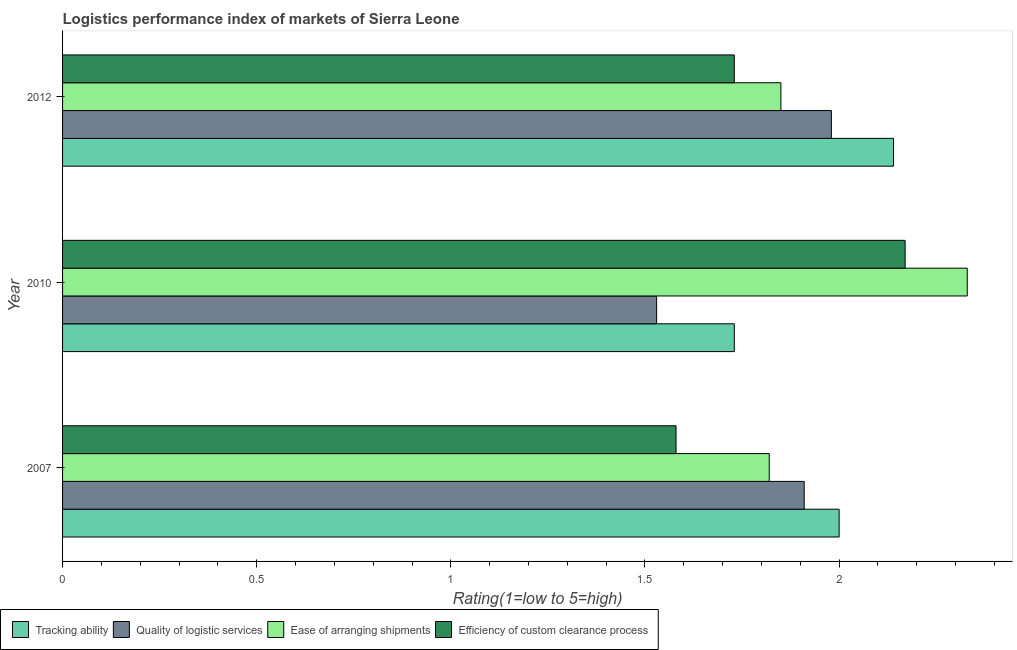How many groups of bars are there?
Give a very brief answer. 3. Are the number of bars per tick equal to the number of legend labels?
Offer a terse response. Yes. How many bars are there on the 2nd tick from the bottom?
Offer a terse response. 4. What is the lpi rating of efficiency of custom clearance process in 2012?
Your answer should be very brief. 1.73. Across all years, what is the maximum lpi rating of ease of arranging shipments?
Ensure brevity in your answer.  2.33. Across all years, what is the minimum lpi rating of quality of logistic services?
Ensure brevity in your answer.  1.53. In which year was the lpi rating of quality of logistic services maximum?
Make the answer very short. 2012. What is the total lpi rating of ease of arranging shipments in the graph?
Keep it short and to the point. 6. What is the difference between the lpi rating of efficiency of custom clearance process in 2007 and that in 2012?
Your answer should be very brief. -0.15. What is the difference between the lpi rating of ease of arranging shipments in 2010 and the lpi rating of tracking ability in 2007?
Offer a terse response. 0.33. What is the average lpi rating of ease of arranging shipments per year?
Give a very brief answer. 2. In the year 2012, what is the difference between the lpi rating of tracking ability and lpi rating of quality of logistic services?
Make the answer very short. 0.16. In how many years, is the lpi rating of tracking ability greater than 1.7 ?
Ensure brevity in your answer.  3. What is the ratio of the lpi rating of efficiency of custom clearance process in 2007 to that in 2010?
Provide a short and direct response. 0.73. Is the lpi rating of quality of logistic services in 2010 less than that in 2012?
Your answer should be compact. Yes. Is the difference between the lpi rating of tracking ability in 2010 and 2012 greater than the difference between the lpi rating of ease of arranging shipments in 2010 and 2012?
Your answer should be very brief. No. What is the difference between the highest and the second highest lpi rating of efficiency of custom clearance process?
Provide a short and direct response. 0.44. What is the difference between the highest and the lowest lpi rating of efficiency of custom clearance process?
Provide a succinct answer. 0.59. In how many years, is the lpi rating of ease of arranging shipments greater than the average lpi rating of ease of arranging shipments taken over all years?
Offer a very short reply. 1. Is the sum of the lpi rating of quality of logistic services in 2007 and 2010 greater than the maximum lpi rating of tracking ability across all years?
Ensure brevity in your answer.  Yes. Is it the case that in every year, the sum of the lpi rating of quality of logistic services and lpi rating of tracking ability is greater than the sum of lpi rating of ease of arranging shipments and lpi rating of efficiency of custom clearance process?
Provide a short and direct response. No. What does the 2nd bar from the top in 2007 represents?
Keep it short and to the point. Ease of arranging shipments. What does the 4th bar from the bottom in 2007 represents?
Provide a succinct answer. Efficiency of custom clearance process. Is it the case that in every year, the sum of the lpi rating of tracking ability and lpi rating of quality of logistic services is greater than the lpi rating of ease of arranging shipments?
Provide a succinct answer. Yes. Are all the bars in the graph horizontal?
Keep it short and to the point. Yes. How many years are there in the graph?
Ensure brevity in your answer.  3. What is the difference between two consecutive major ticks on the X-axis?
Keep it short and to the point. 0.5. Are the values on the major ticks of X-axis written in scientific E-notation?
Offer a very short reply. No. Does the graph contain any zero values?
Your response must be concise. No. Does the graph contain grids?
Offer a terse response. No. What is the title of the graph?
Provide a succinct answer. Logistics performance index of markets of Sierra Leone. Does "Labor Taxes" appear as one of the legend labels in the graph?
Offer a very short reply. No. What is the label or title of the X-axis?
Give a very brief answer. Rating(1=low to 5=high). What is the Rating(1=low to 5=high) in Quality of logistic services in 2007?
Offer a terse response. 1.91. What is the Rating(1=low to 5=high) in Ease of arranging shipments in 2007?
Make the answer very short. 1.82. What is the Rating(1=low to 5=high) of Efficiency of custom clearance process in 2007?
Your answer should be compact. 1.58. What is the Rating(1=low to 5=high) in Tracking ability in 2010?
Provide a short and direct response. 1.73. What is the Rating(1=low to 5=high) of Quality of logistic services in 2010?
Your response must be concise. 1.53. What is the Rating(1=low to 5=high) of Ease of arranging shipments in 2010?
Give a very brief answer. 2.33. What is the Rating(1=low to 5=high) of Efficiency of custom clearance process in 2010?
Give a very brief answer. 2.17. What is the Rating(1=low to 5=high) in Tracking ability in 2012?
Your answer should be compact. 2.14. What is the Rating(1=low to 5=high) in Quality of logistic services in 2012?
Make the answer very short. 1.98. What is the Rating(1=low to 5=high) of Ease of arranging shipments in 2012?
Make the answer very short. 1.85. What is the Rating(1=low to 5=high) in Efficiency of custom clearance process in 2012?
Your answer should be compact. 1.73. Across all years, what is the maximum Rating(1=low to 5=high) of Tracking ability?
Provide a succinct answer. 2.14. Across all years, what is the maximum Rating(1=low to 5=high) of Quality of logistic services?
Keep it short and to the point. 1.98. Across all years, what is the maximum Rating(1=low to 5=high) of Ease of arranging shipments?
Offer a very short reply. 2.33. Across all years, what is the maximum Rating(1=low to 5=high) in Efficiency of custom clearance process?
Offer a terse response. 2.17. Across all years, what is the minimum Rating(1=low to 5=high) in Tracking ability?
Offer a very short reply. 1.73. Across all years, what is the minimum Rating(1=low to 5=high) in Quality of logistic services?
Offer a very short reply. 1.53. Across all years, what is the minimum Rating(1=low to 5=high) of Ease of arranging shipments?
Make the answer very short. 1.82. Across all years, what is the minimum Rating(1=low to 5=high) in Efficiency of custom clearance process?
Give a very brief answer. 1.58. What is the total Rating(1=low to 5=high) of Tracking ability in the graph?
Offer a terse response. 5.87. What is the total Rating(1=low to 5=high) of Quality of logistic services in the graph?
Offer a very short reply. 5.42. What is the total Rating(1=low to 5=high) of Ease of arranging shipments in the graph?
Your answer should be compact. 6. What is the total Rating(1=low to 5=high) in Efficiency of custom clearance process in the graph?
Offer a very short reply. 5.48. What is the difference between the Rating(1=low to 5=high) of Tracking ability in 2007 and that in 2010?
Your response must be concise. 0.27. What is the difference between the Rating(1=low to 5=high) in Quality of logistic services in 2007 and that in 2010?
Your answer should be very brief. 0.38. What is the difference between the Rating(1=low to 5=high) in Ease of arranging shipments in 2007 and that in 2010?
Your answer should be very brief. -0.51. What is the difference between the Rating(1=low to 5=high) of Efficiency of custom clearance process in 2007 and that in 2010?
Your answer should be very brief. -0.59. What is the difference between the Rating(1=low to 5=high) in Tracking ability in 2007 and that in 2012?
Give a very brief answer. -0.14. What is the difference between the Rating(1=low to 5=high) of Quality of logistic services in 2007 and that in 2012?
Keep it short and to the point. -0.07. What is the difference between the Rating(1=low to 5=high) in Ease of arranging shipments in 2007 and that in 2012?
Give a very brief answer. -0.03. What is the difference between the Rating(1=low to 5=high) in Efficiency of custom clearance process in 2007 and that in 2012?
Keep it short and to the point. -0.15. What is the difference between the Rating(1=low to 5=high) of Tracking ability in 2010 and that in 2012?
Give a very brief answer. -0.41. What is the difference between the Rating(1=low to 5=high) of Quality of logistic services in 2010 and that in 2012?
Provide a succinct answer. -0.45. What is the difference between the Rating(1=low to 5=high) in Ease of arranging shipments in 2010 and that in 2012?
Your answer should be compact. 0.48. What is the difference between the Rating(1=low to 5=high) in Efficiency of custom clearance process in 2010 and that in 2012?
Give a very brief answer. 0.44. What is the difference between the Rating(1=low to 5=high) of Tracking ability in 2007 and the Rating(1=low to 5=high) of Quality of logistic services in 2010?
Your answer should be compact. 0.47. What is the difference between the Rating(1=low to 5=high) in Tracking ability in 2007 and the Rating(1=low to 5=high) in Ease of arranging shipments in 2010?
Provide a succinct answer. -0.33. What is the difference between the Rating(1=low to 5=high) of Tracking ability in 2007 and the Rating(1=low to 5=high) of Efficiency of custom clearance process in 2010?
Provide a short and direct response. -0.17. What is the difference between the Rating(1=low to 5=high) in Quality of logistic services in 2007 and the Rating(1=low to 5=high) in Ease of arranging shipments in 2010?
Provide a succinct answer. -0.42. What is the difference between the Rating(1=low to 5=high) in Quality of logistic services in 2007 and the Rating(1=low to 5=high) in Efficiency of custom clearance process in 2010?
Ensure brevity in your answer.  -0.26. What is the difference between the Rating(1=low to 5=high) of Ease of arranging shipments in 2007 and the Rating(1=low to 5=high) of Efficiency of custom clearance process in 2010?
Give a very brief answer. -0.35. What is the difference between the Rating(1=low to 5=high) in Tracking ability in 2007 and the Rating(1=low to 5=high) in Efficiency of custom clearance process in 2012?
Your answer should be compact. 0.27. What is the difference between the Rating(1=low to 5=high) in Quality of logistic services in 2007 and the Rating(1=low to 5=high) in Efficiency of custom clearance process in 2012?
Provide a succinct answer. 0.18. What is the difference between the Rating(1=low to 5=high) in Ease of arranging shipments in 2007 and the Rating(1=low to 5=high) in Efficiency of custom clearance process in 2012?
Keep it short and to the point. 0.09. What is the difference between the Rating(1=low to 5=high) in Tracking ability in 2010 and the Rating(1=low to 5=high) in Quality of logistic services in 2012?
Make the answer very short. -0.25. What is the difference between the Rating(1=low to 5=high) in Tracking ability in 2010 and the Rating(1=low to 5=high) in Ease of arranging shipments in 2012?
Your answer should be compact. -0.12. What is the difference between the Rating(1=low to 5=high) in Quality of logistic services in 2010 and the Rating(1=low to 5=high) in Ease of arranging shipments in 2012?
Keep it short and to the point. -0.32. What is the difference between the Rating(1=low to 5=high) in Quality of logistic services in 2010 and the Rating(1=low to 5=high) in Efficiency of custom clearance process in 2012?
Provide a short and direct response. -0.2. What is the average Rating(1=low to 5=high) in Tracking ability per year?
Your answer should be very brief. 1.96. What is the average Rating(1=low to 5=high) of Quality of logistic services per year?
Make the answer very short. 1.81. What is the average Rating(1=low to 5=high) of Ease of arranging shipments per year?
Make the answer very short. 2. What is the average Rating(1=low to 5=high) in Efficiency of custom clearance process per year?
Ensure brevity in your answer.  1.83. In the year 2007, what is the difference between the Rating(1=low to 5=high) of Tracking ability and Rating(1=low to 5=high) of Quality of logistic services?
Ensure brevity in your answer.  0.09. In the year 2007, what is the difference between the Rating(1=low to 5=high) of Tracking ability and Rating(1=low to 5=high) of Ease of arranging shipments?
Your response must be concise. 0.18. In the year 2007, what is the difference between the Rating(1=low to 5=high) of Tracking ability and Rating(1=low to 5=high) of Efficiency of custom clearance process?
Make the answer very short. 0.42. In the year 2007, what is the difference between the Rating(1=low to 5=high) in Quality of logistic services and Rating(1=low to 5=high) in Ease of arranging shipments?
Keep it short and to the point. 0.09. In the year 2007, what is the difference between the Rating(1=low to 5=high) of Quality of logistic services and Rating(1=low to 5=high) of Efficiency of custom clearance process?
Give a very brief answer. 0.33. In the year 2007, what is the difference between the Rating(1=low to 5=high) of Ease of arranging shipments and Rating(1=low to 5=high) of Efficiency of custom clearance process?
Offer a very short reply. 0.24. In the year 2010, what is the difference between the Rating(1=low to 5=high) in Tracking ability and Rating(1=low to 5=high) in Quality of logistic services?
Ensure brevity in your answer.  0.2. In the year 2010, what is the difference between the Rating(1=low to 5=high) of Tracking ability and Rating(1=low to 5=high) of Efficiency of custom clearance process?
Give a very brief answer. -0.44. In the year 2010, what is the difference between the Rating(1=low to 5=high) in Quality of logistic services and Rating(1=low to 5=high) in Efficiency of custom clearance process?
Your answer should be very brief. -0.64. In the year 2010, what is the difference between the Rating(1=low to 5=high) of Ease of arranging shipments and Rating(1=low to 5=high) of Efficiency of custom clearance process?
Offer a terse response. 0.16. In the year 2012, what is the difference between the Rating(1=low to 5=high) of Tracking ability and Rating(1=low to 5=high) of Quality of logistic services?
Provide a short and direct response. 0.16. In the year 2012, what is the difference between the Rating(1=low to 5=high) in Tracking ability and Rating(1=low to 5=high) in Ease of arranging shipments?
Offer a terse response. 0.29. In the year 2012, what is the difference between the Rating(1=low to 5=high) in Tracking ability and Rating(1=low to 5=high) in Efficiency of custom clearance process?
Offer a very short reply. 0.41. In the year 2012, what is the difference between the Rating(1=low to 5=high) of Quality of logistic services and Rating(1=low to 5=high) of Ease of arranging shipments?
Provide a succinct answer. 0.13. In the year 2012, what is the difference between the Rating(1=low to 5=high) of Ease of arranging shipments and Rating(1=low to 5=high) of Efficiency of custom clearance process?
Ensure brevity in your answer.  0.12. What is the ratio of the Rating(1=low to 5=high) of Tracking ability in 2007 to that in 2010?
Your response must be concise. 1.16. What is the ratio of the Rating(1=low to 5=high) in Quality of logistic services in 2007 to that in 2010?
Provide a succinct answer. 1.25. What is the ratio of the Rating(1=low to 5=high) of Ease of arranging shipments in 2007 to that in 2010?
Your answer should be compact. 0.78. What is the ratio of the Rating(1=low to 5=high) of Efficiency of custom clearance process in 2007 to that in 2010?
Make the answer very short. 0.73. What is the ratio of the Rating(1=low to 5=high) of Tracking ability in 2007 to that in 2012?
Your response must be concise. 0.93. What is the ratio of the Rating(1=low to 5=high) in Quality of logistic services in 2007 to that in 2012?
Provide a short and direct response. 0.96. What is the ratio of the Rating(1=low to 5=high) of Ease of arranging shipments in 2007 to that in 2012?
Make the answer very short. 0.98. What is the ratio of the Rating(1=low to 5=high) in Efficiency of custom clearance process in 2007 to that in 2012?
Give a very brief answer. 0.91. What is the ratio of the Rating(1=low to 5=high) in Tracking ability in 2010 to that in 2012?
Keep it short and to the point. 0.81. What is the ratio of the Rating(1=low to 5=high) of Quality of logistic services in 2010 to that in 2012?
Make the answer very short. 0.77. What is the ratio of the Rating(1=low to 5=high) in Ease of arranging shipments in 2010 to that in 2012?
Provide a succinct answer. 1.26. What is the ratio of the Rating(1=low to 5=high) in Efficiency of custom clearance process in 2010 to that in 2012?
Provide a short and direct response. 1.25. What is the difference between the highest and the second highest Rating(1=low to 5=high) of Tracking ability?
Ensure brevity in your answer.  0.14. What is the difference between the highest and the second highest Rating(1=low to 5=high) of Quality of logistic services?
Keep it short and to the point. 0.07. What is the difference between the highest and the second highest Rating(1=low to 5=high) in Ease of arranging shipments?
Keep it short and to the point. 0.48. What is the difference between the highest and the second highest Rating(1=low to 5=high) of Efficiency of custom clearance process?
Offer a terse response. 0.44. What is the difference between the highest and the lowest Rating(1=low to 5=high) in Tracking ability?
Your answer should be compact. 0.41. What is the difference between the highest and the lowest Rating(1=low to 5=high) of Quality of logistic services?
Your response must be concise. 0.45. What is the difference between the highest and the lowest Rating(1=low to 5=high) in Ease of arranging shipments?
Make the answer very short. 0.51. What is the difference between the highest and the lowest Rating(1=low to 5=high) of Efficiency of custom clearance process?
Offer a terse response. 0.59. 